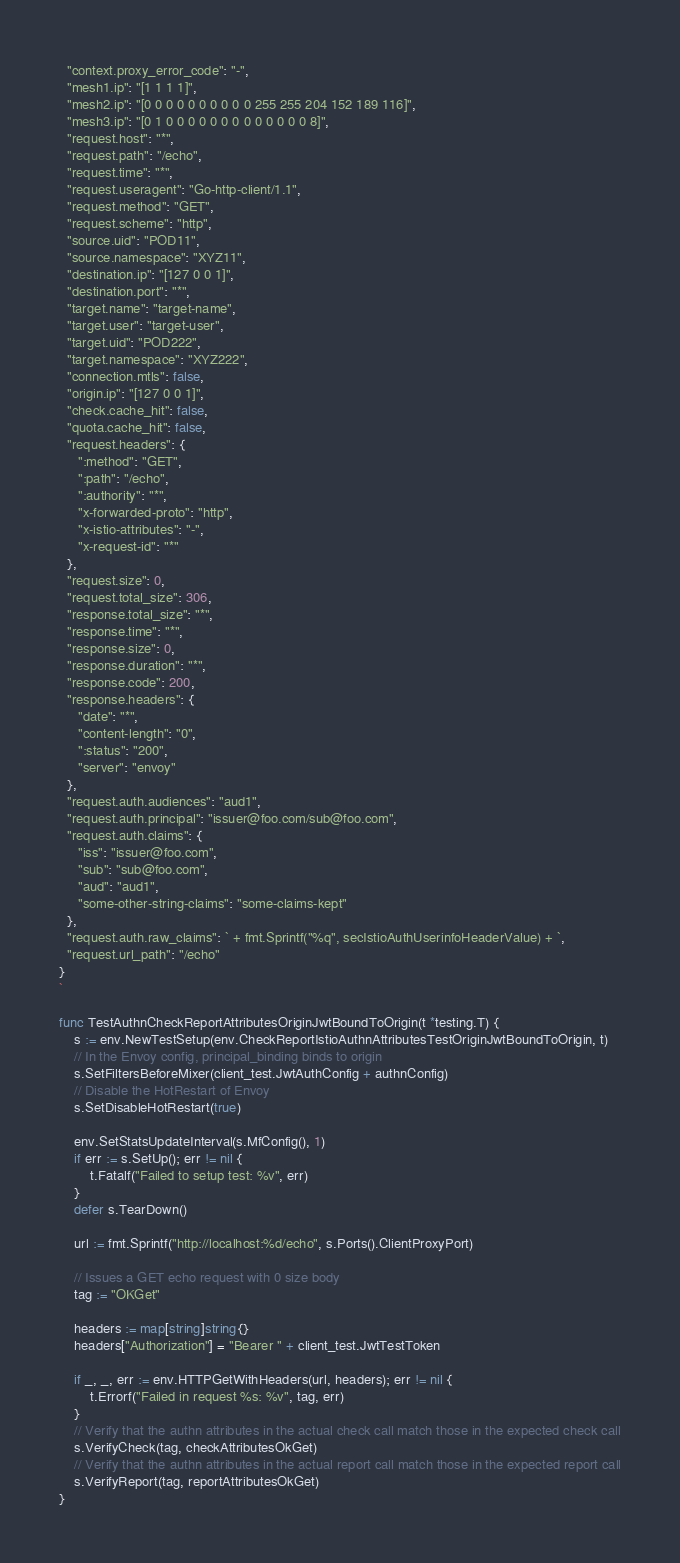Convert code to text. <code><loc_0><loc_0><loc_500><loc_500><_Go_>  "context.proxy_error_code": "-",
  "mesh1.ip": "[1 1 1 1]",
  "mesh2.ip": "[0 0 0 0 0 0 0 0 0 0 255 255 204 152 189 116]",
  "mesh3.ip": "[0 1 0 0 0 0 0 0 0 0 0 0 0 0 0 8]",
  "request.host": "*",
  "request.path": "/echo",
  "request.time": "*",
  "request.useragent": "Go-http-client/1.1",
  "request.method": "GET",
  "request.scheme": "http",
  "source.uid": "POD11",
  "source.namespace": "XYZ11",
  "destination.ip": "[127 0 0 1]",
  "destination.port": "*",
  "target.name": "target-name",
  "target.user": "target-user",
  "target.uid": "POD222",
  "target.namespace": "XYZ222",
  "connection.mtls": false,
  "origin.ip": "[127 0 0 1]",
  "check.cache_hit": false,
  "quota.cache_hit": false,
  "request.headers": {
     ":method": "GET",
     ":path": "/echo",
     ":authority": "*",
     "x-forwarded-proto": "http",
     "x-istio-attributes": "-",
     "x-request-id": "*"
  },
  "request.size": 0,
  "request.total_size": 306,
  "response.total_size": "*",
  "response.time": "*",
  "response.size": 0,
  "response.duration": "*",
  "response.code": 200,
  "response.headers": {
     "date": "*",
     "content-length": "0",
     ":status": "200",
     "server": "envoy"
  },
  "request.auth.audiences": "aud1",
  "request.auth.principal": "issuer@foo.com/sub@foo.com",
  "request.auth.claims": {
     "iss": "issuer@foo.com",
     "sub": "sub@foo.com",
     "aud": "aud1",
     "some-other-string-claims": "some-claims-kept"
  },
  "request.auth.raw_claims": ` + fmt.Sprintf("%q", secIstioAuthUserinfoHeaderValue) + `,
  "request.url_path": "/echo"
}
`

func TestAuthnCheckReportAttributesOriginJwtBoundToOrigin(t *testing.T) {
	s := env.NewTestSetup(env.CheckReportIstioAuthnAttributesTestOriginJwtBoundToOrigin, t)
	// In the Envoy config, principal_binding binds to origin
	s.SetFiltersBeforeMixer(client_test.JwtAuthConfig + authnConfig)
	// Disable the HotRestart of Envoy
	s.SetDisableHotRestart(true)

	env.SetStatsUpdateInterval(s.MfConfig(), 1)
	if err := s.SetUp(); err != nil {
		t.Fatalf("Failed to setup test: %v", err)
	}
	defer s.TearDown()

	url := fmt.Sprintf("http://localhost:%d/echo", s.Ports().ClientProxyPort)

	// Issues a GET echo request with 0 size body
	tag := "OKGet"

	headers := map[string]string{}
	headers["Authorization"] = "Bearer " + client_test.JwtTestToken

	if _, _, err := env.HTTPGetWithHeaders(url, headers); err != nil {
		t.Errorf("Failed in request %s: %v", tag, err)
	}
	// Verify that the authn attributes in the actual check call match those in the expected check call
	s.VerifyCheck(tag, checkAttributesOkGet)
	// Verify that the authn attributes in the actual report call match those in the expected report call
	s.VerifyReport(tag, reportAttributesOkGet)
}
</code> 